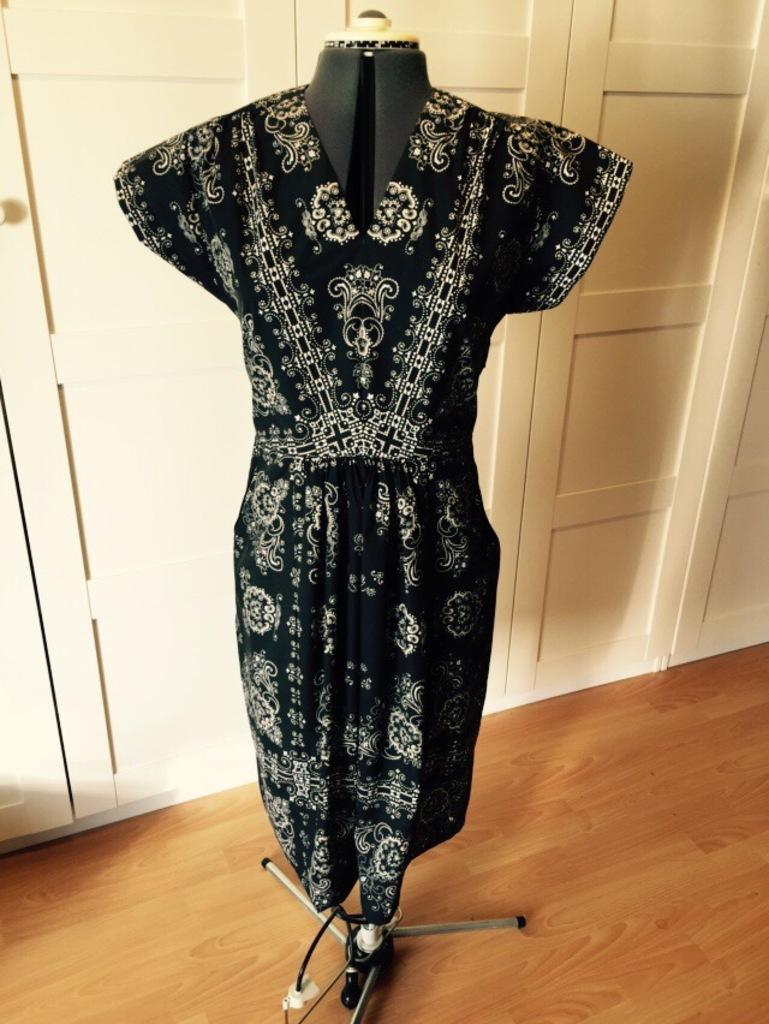What color is the dress in the image? The dress in the image is black and white. Where is the dress located? The dress is on a wooden floor. What can be seen on the wall in the image? There is a white wall in the image. Can you see any crackers or tigers in the image? No, there are no crackers or tigers present in the image. 